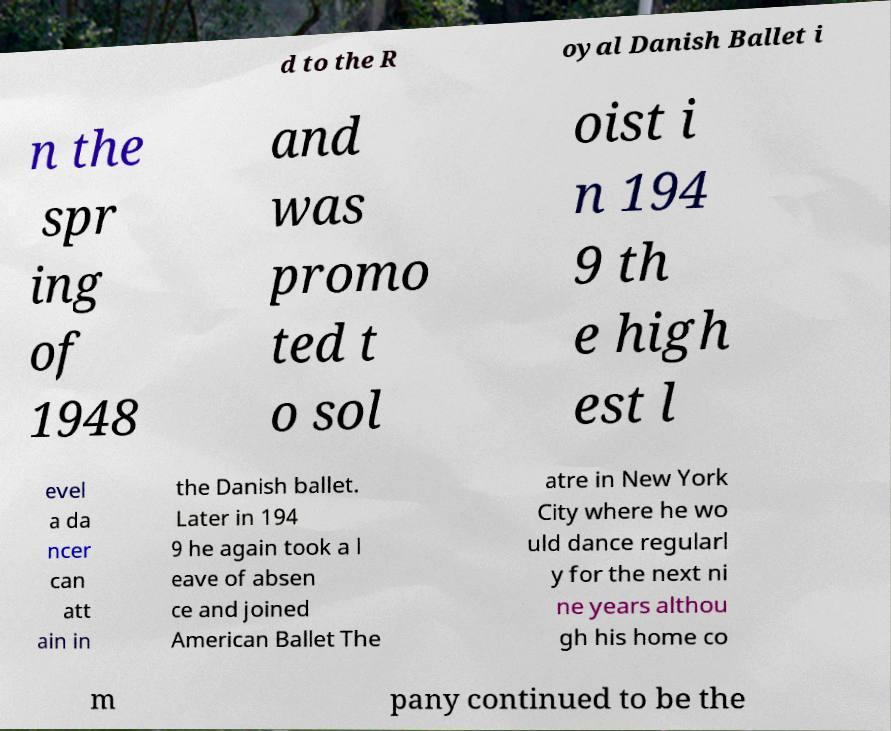Can you read and provide the text displayed in the image?This photo seems to have some interesting text. Can you extract and type it out for me? d to the R oyal Danish Ballet i n the spr ing of 1948 and was promo ted t o sol oist i n 194 9 th e high est l evel a da ncer can att ain in the Danish ballet. Later in 194 9 he again took a l eave of absen ce and joined American Ballet The atre in New York City where he wo uld dance regularl y for the next ni ne years althou gh his home co m pany continued to be the 